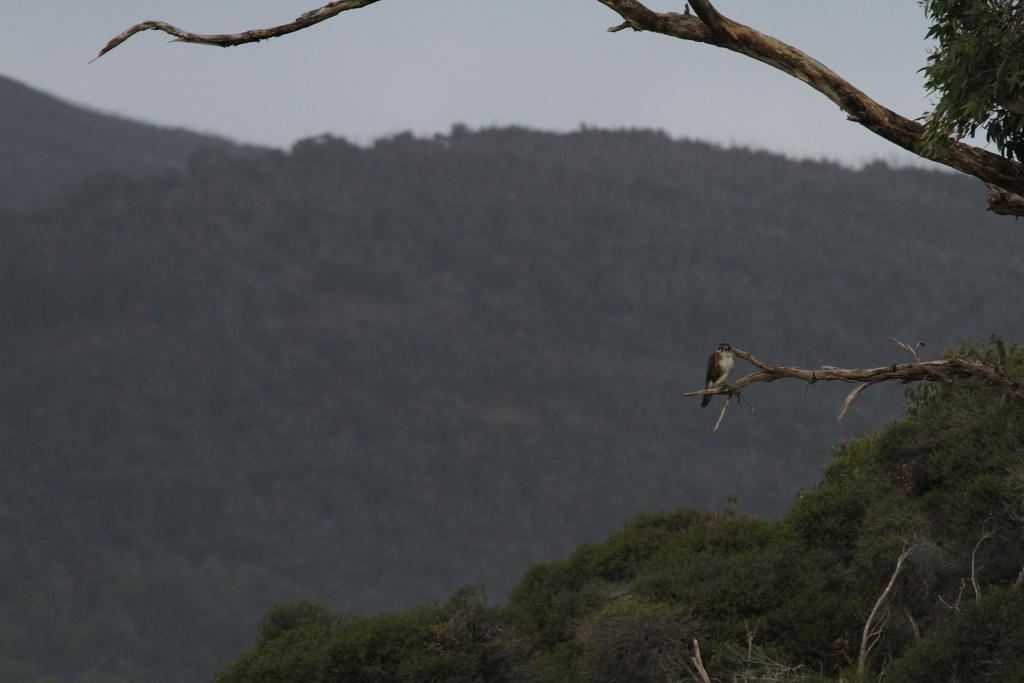What type of animal can be seen in the image? There is a bird in the image. Where is the bird located in the image? The bird is standing on a branch. Which side of the image does the branch appear on? The branch is on the left side of the image. What can be seen in the background of the image? There is a hill with trees in the image, and the sky is visible above the hill. What color is the headboard of the bed in the image? There is no bed or headboard present in the image; it features a bird standing on a branch with a hill and trees in the background. 